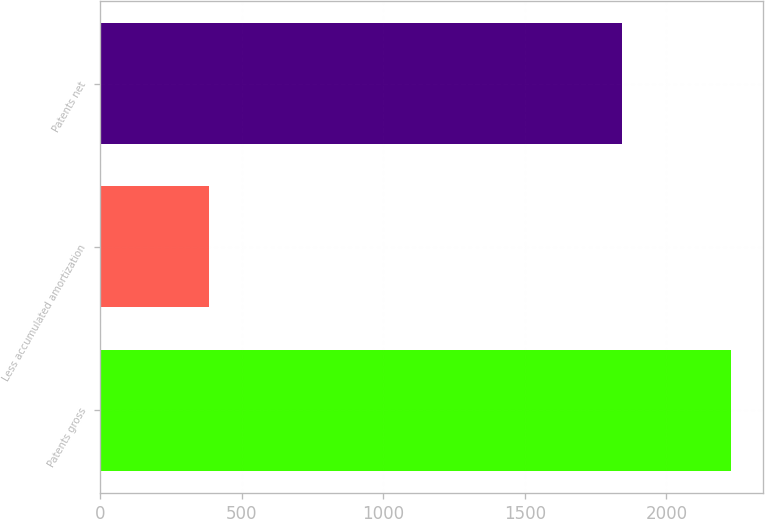Convert chart. <chart><loc_0><loc_0><loc_500><loc_500><bar_chart><fcel>Patents gross<fcel>Less accumulated amortization<fcel>Patents net<nl><fcel>2229<fcel>385<fcel>1844<nl></chart> 